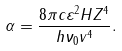Convert formula to latex. <formula><loc_0><loc_0><loc_500><loc_500>\alpha = \frac { 8 \pi c \varepsilon ^ { 2 } H Z ^ { 4 } } { h \nu _ { 0 } v ^ { 4 } } .</formula> 